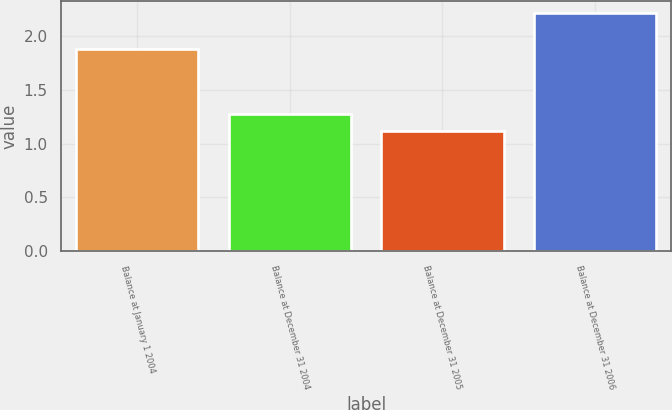Convert chart. <chart><loc_0><loc_0><loc_500><loc_500><bar_chart><fcel>Balance at January 1 2004<fcel>Balance at December 31 2004<fcel>Balance at December 31 2005<fcel>Balance at December 31 2006<nl><fcel>1.88<fcel>1.28<fcel>1.12<fcel>2.22<nl></chart> 